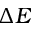Convert formula to latex. <formula><loc_0><loc_0><loc_500><loc_500>\Delta E</formula> 